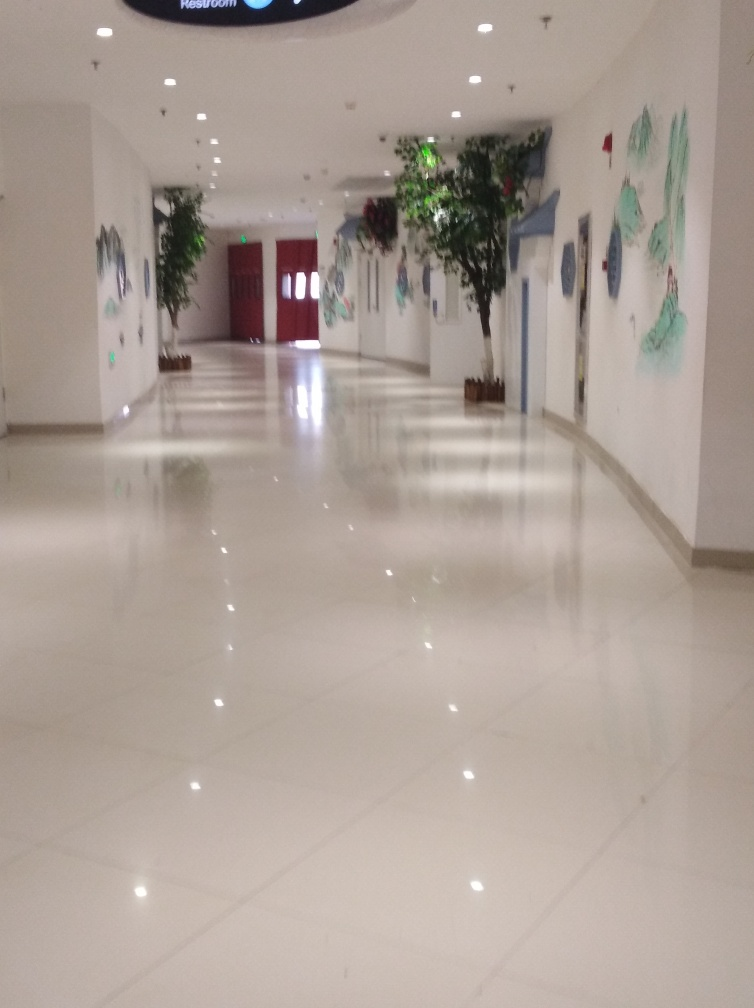How is the color coordination of the photo?
A. Vibrant
B. Harmonious
C. Dull
D. Clashing
Answer with the option's letter from the given choices directly. The color coordination in the photo can be characterized as B. Harmonious, given the subtle and calming color palette utilized throughout the space. The reflection on the glossy floor enhances the sense of order and tranquility, while the artwork and greenery add just enough contrast and interest without overwhelming the viewer or creating a sense of discord. 